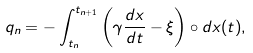<formula> <loc_0><loc_0><loc_500><loc_500>q _ { n } = - \int _ { t _ { n } } ^ { t _ { n + 1 } } \left ( \gamma \frac { d x } { d t } - \xi \right ) \circ d x ( t ) ,</formula> 